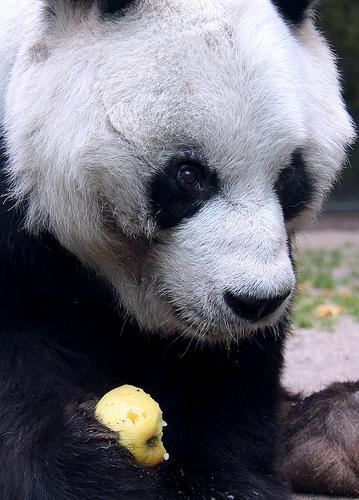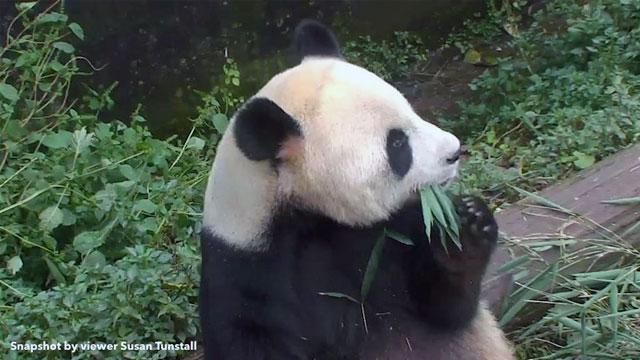The first image is the image on the left, the second image is the image on the right. For the images displayed, is the sentence "One image features one forward-facing panda chewing green leaves, with the paw on the left raised and curled over." factually correct? Answer yes or no. No. The first image is the image on the left, the second image is the image on the right. Given the left and right images, does the statement "There are two pandas eating." hold true? Answer yes or no. Yes. 